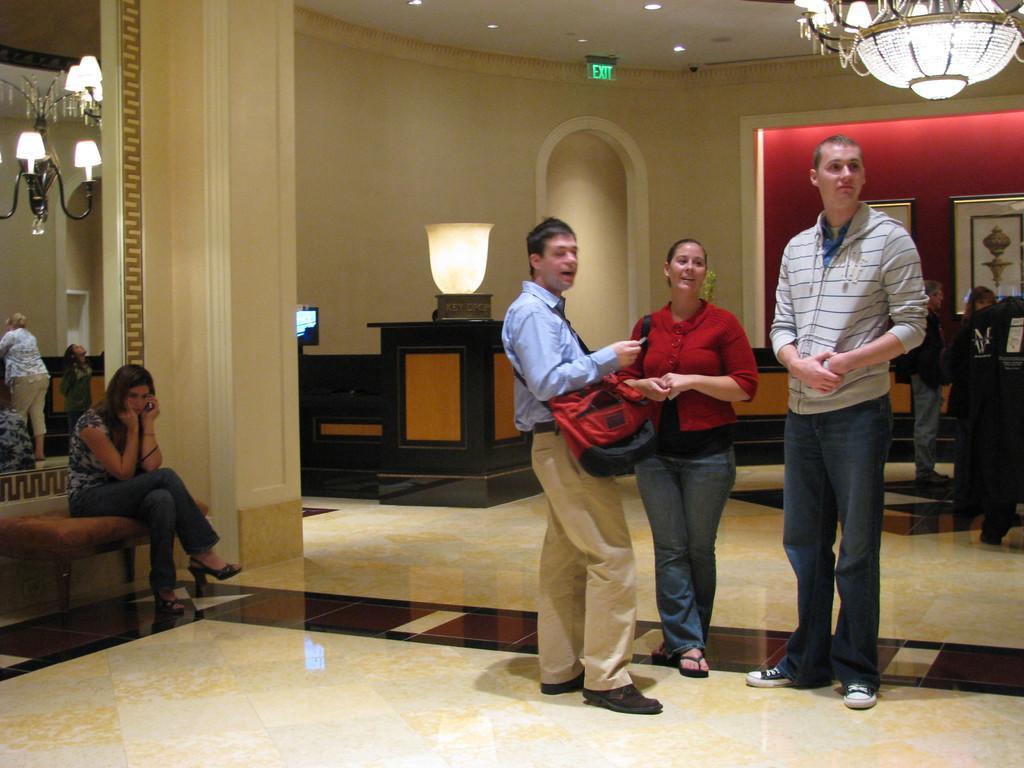Can you describe this image briefly? In this picture there is a man who is wearing shirt and shoes. He is holding a red bag, besides him there is a woman who is wearing red shirt, jeans and slippers. Besides her there is a man who is wearing hoodie, t shirt, jeans and shoes. In the top right corner there is a chandelier. On the left there is a woman who is sitting on the bench and holding a mobile phone. Beside her there are some people were standing near on the wall. In the back I can see some people were standing near to the frames. At the top I can see the lights and exit sign board. Beside the table there is a door. 